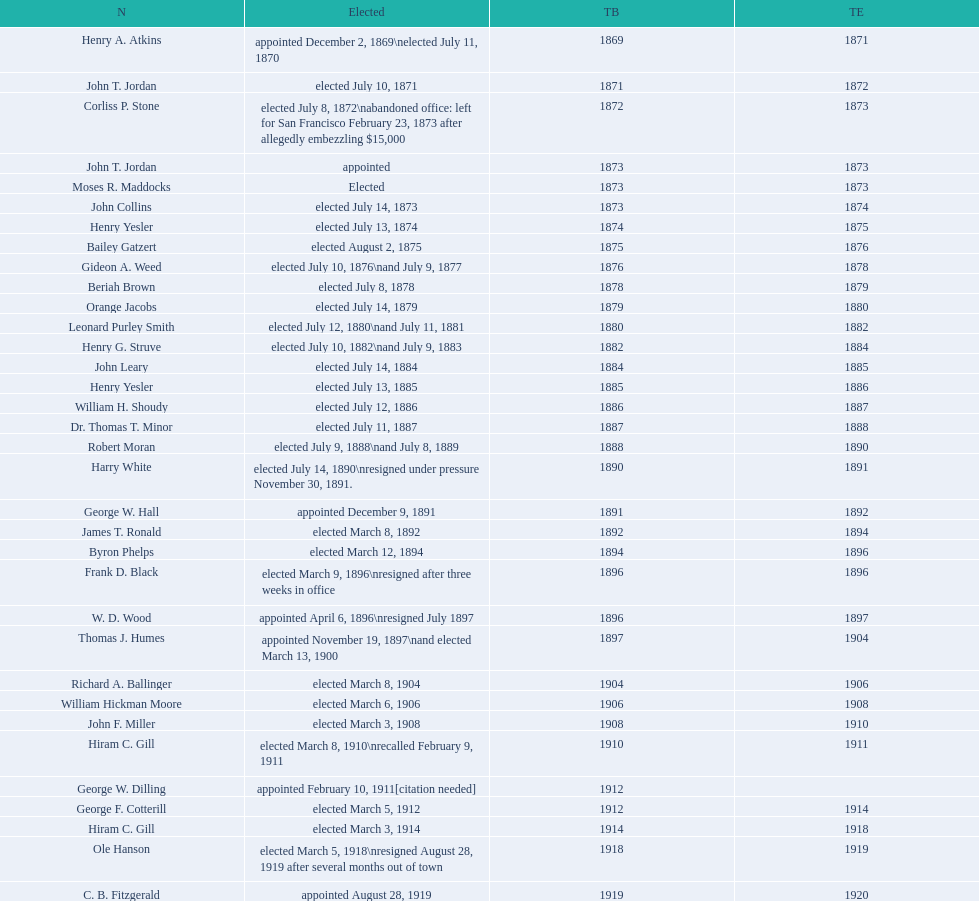The number of mayors with the first name john is? 6. 